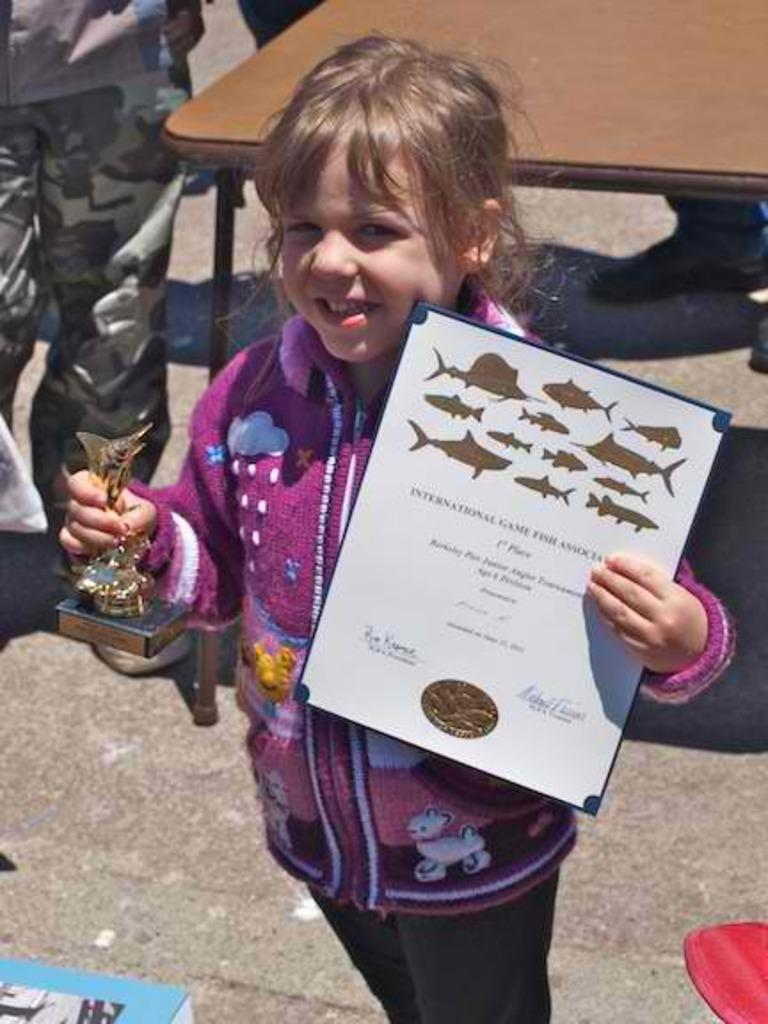Who is the main subject in the image? There is a girl in the image. What is the girl holding in her hands? The girl is holding a certificate and a trophy. Where is the girl standing in the image? The girl is standing on the road. What is the girl's expression in the image? The girl is smiling. What can be seen in the background of the image? There is a table and people in the background of the image. What type of feather can be seen on the girl's hat in the image? There is no feather visible on the girl's hat in the image. What kind of competition is the girl participating in, as indicated by the trophy? The image does not specify the type of competition or event that the girl participated in; it only shows her holding a trophy. 